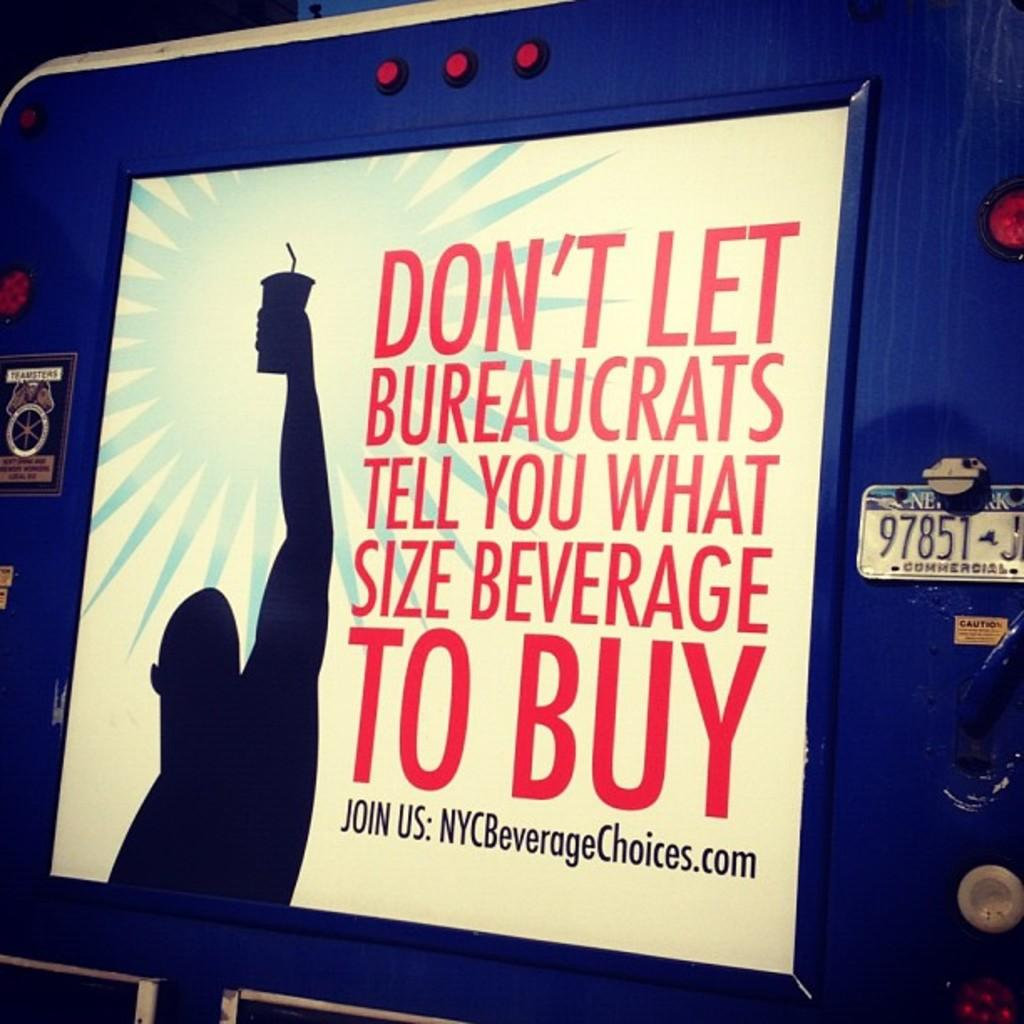<image>
Present a compact description of the photo's key features. A protest sign against New York drink sizes with a website link titled NYCBeverageChoices on it. 